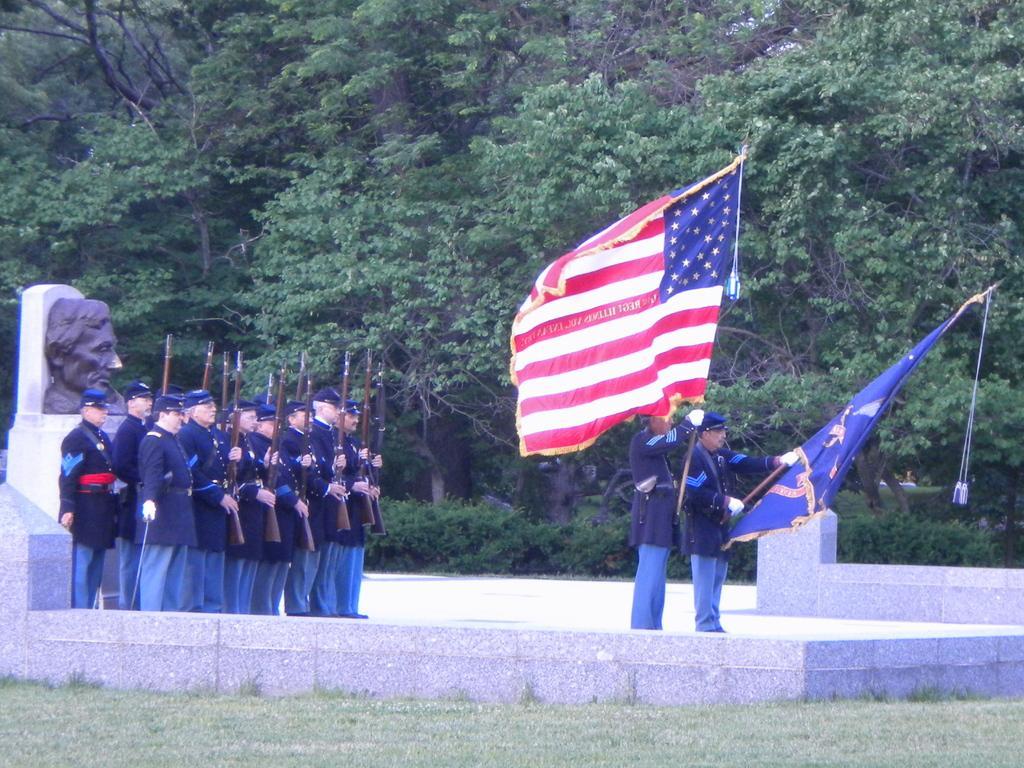Can you describe this image briefly? This picture describes about group of people, they are standing, few people are holding guns and few people holding flags, behind to them we can see a sculpture, in the background we can find few trees. 